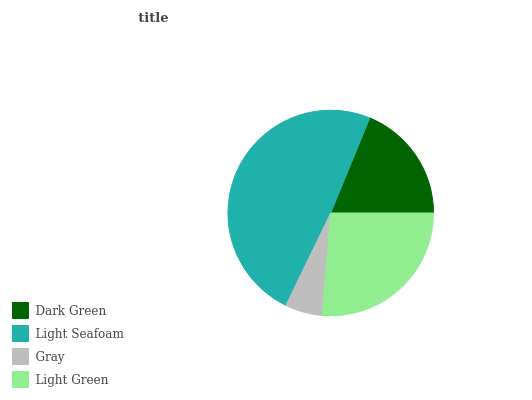Is Gray the minimum?
Answer yes or no. Yes. Is Light Seafoam the maximum?
Answer yes or no. Yes. Is Light Seafoam the minimum?
Answer yes or no. No. Is Gray the maximum?
Answer yes or no. No. Is Light Seafoam greater than Gray?
Answer yes or no. Yes. Is Gray less than Light Seafoam?
Answer yes or no. Yes. Is Gray greater than Light Seafoam?
Answer yes or no. No. Is Light Seafoam less than Gray?
Answer yes or no. No. Is Light Green the high median?
Answer yes or no. Yes. Is Dark Green the low median?
Answer yes or no. Yes. Is Dark Green the high median?
Answer yes or no. No. Is Gray the low median?
Answer yes or no. No. 